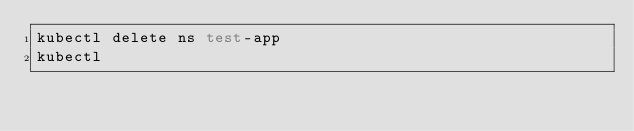<code> <loc_0><loc_0><loc_500><loc_500><_Bash_>kubectl delete ns test-app
kubectl </code> 